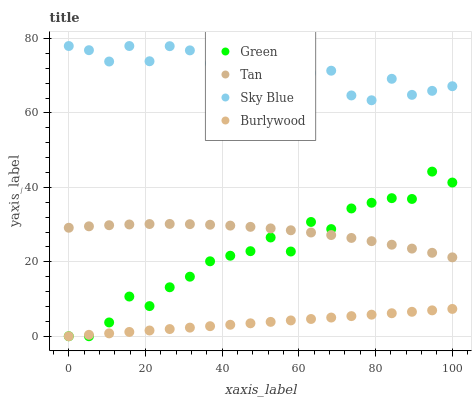Does Burlywood have the minimum area under the curve?
Answer yes or no. Yes. Does Sky Blue have the maximum area under the curve?
Answer yes or no. Yes. Does Tan have the minimum area under the curve?
Answer yes or no. No. Does Tan have the maximum area under the curve?
Answer yes or no. No. Is Burlywood the smoothest?
Answer yes or no. Yes. Is Sky Blue the roughest?
Answer yes or no. Yes. Is Tan the smoothest?
Answer yes or no. No. Is Tan the roughest?
Answer yes or no. No. Does Burlywood have the lowest value?
Answer yes or no. Yes. Does Tan have the lowest value?
Answer yes or no. No. Does Sky Blue have the highest value?
Answer yes or no. Yes. Does Tan have the highest value?
Answer yes or no. No. Is Tan less than Sky Blue?
Answer yes or no. Yes. Is Sky Blue greater than Tan?
Answer yes or no. Yes. Does Tan intersect Green?
Answer yes or no. Yes. Is Tan less than Green?
Answer yes or no. No. Is Tan greater than Green?
Answer yes or no. No. Does Tan intersect Sky Blue?
Answer yes or no. No. 